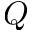<formula> <loc_0><loc_0><loc_500><loc_500>Q</formula> 